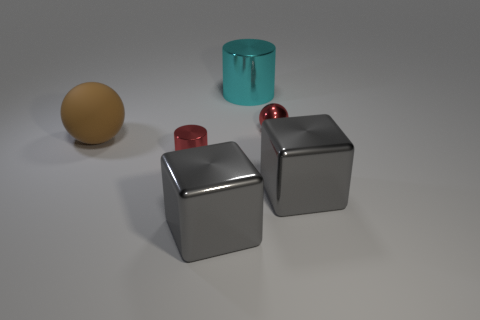There is a red cylinder; does it have the same size as the gray shiny object that is left of the metal sphere?
Ensure brevity in your answer.  No. What is the material of the small red object that is the same shape as the large brown thing?
Ensure brevity in your answer.  Metal. What number of other objects are there of the same size as the brown sphere?
Make the answer very short. 3. There is a gray object on the left side of the cylinder behind the large brown rubber thing in front of the cyan shiny thing; what shape is it?
Provide a short and direct response. Cube. There is a metallic object that is on the left side of the cyan cylinder and in front of the tiny cylinder; what shape is it?
Your answer should be very brief. Cube. How many things are big red rubber cubes or tiny red shiny things behind the big brown sphere?
Provide a short and direct response. 1. Is the material of the big cyan thing the same as the big brown object?
Your answer should be compact. No. How many other things are there of the same shape as the brown rubber object?
Offer a very short reply. 1. What size is the object that is to the right of the cyan metal object and in front of the red metallic ball?
Keep it short and to the point. Large. How many matte objects are either small red cylinders or big blue cubes?
Your answer should be compact. 0. 